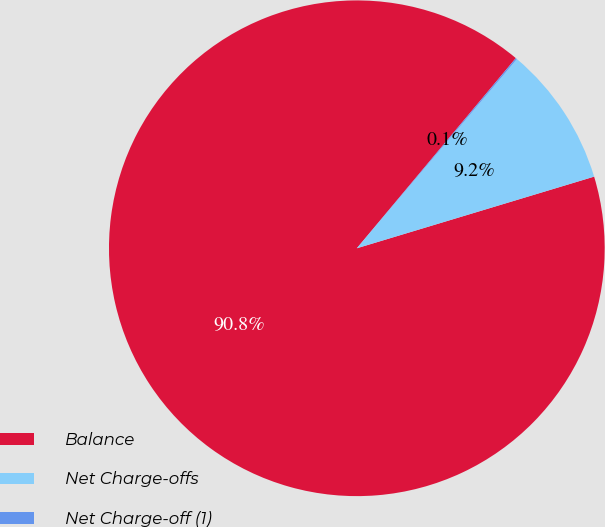<chart> <loc_0><loc_0><loc_500><loc_500><pie_chart><fcel>Balance<fcel>Net Charge-offs<fcel>Net Charge-off (1)<nl><fcel>90.75%<fcel>9.16%<fcel>0.09%<nl></chart> 